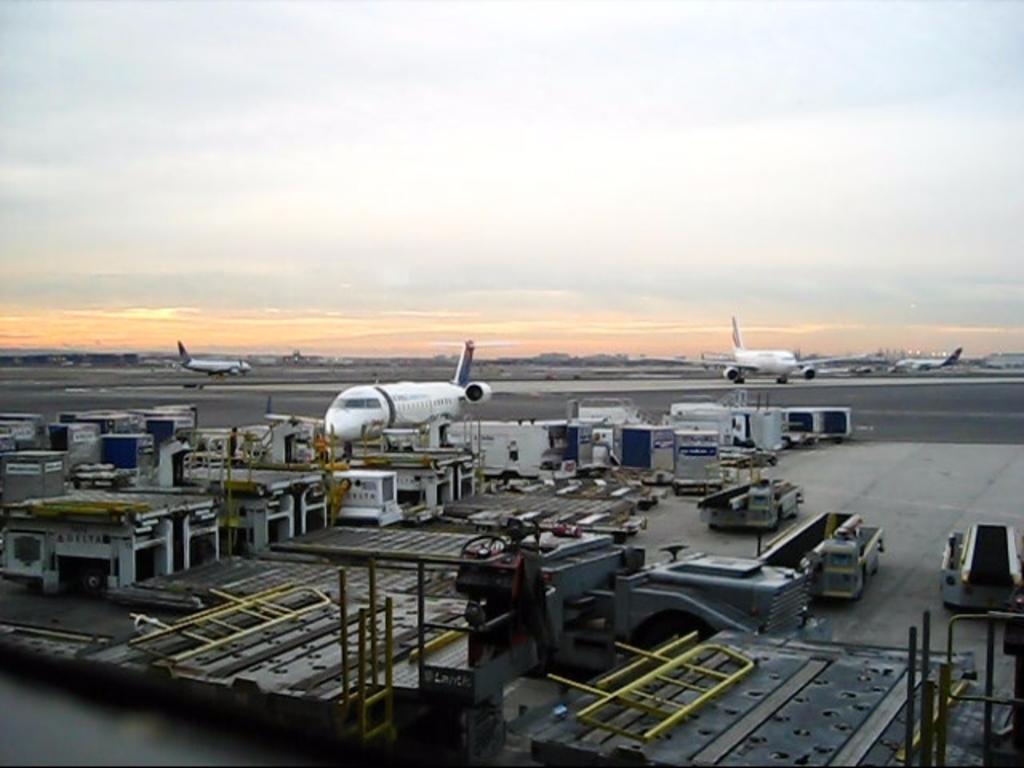In one or two sentences, can you explain what this image depicts? In this image, we can see few aeroplanes, vehicles, some objects, rods and machines. Background there is a cloudy sky. 